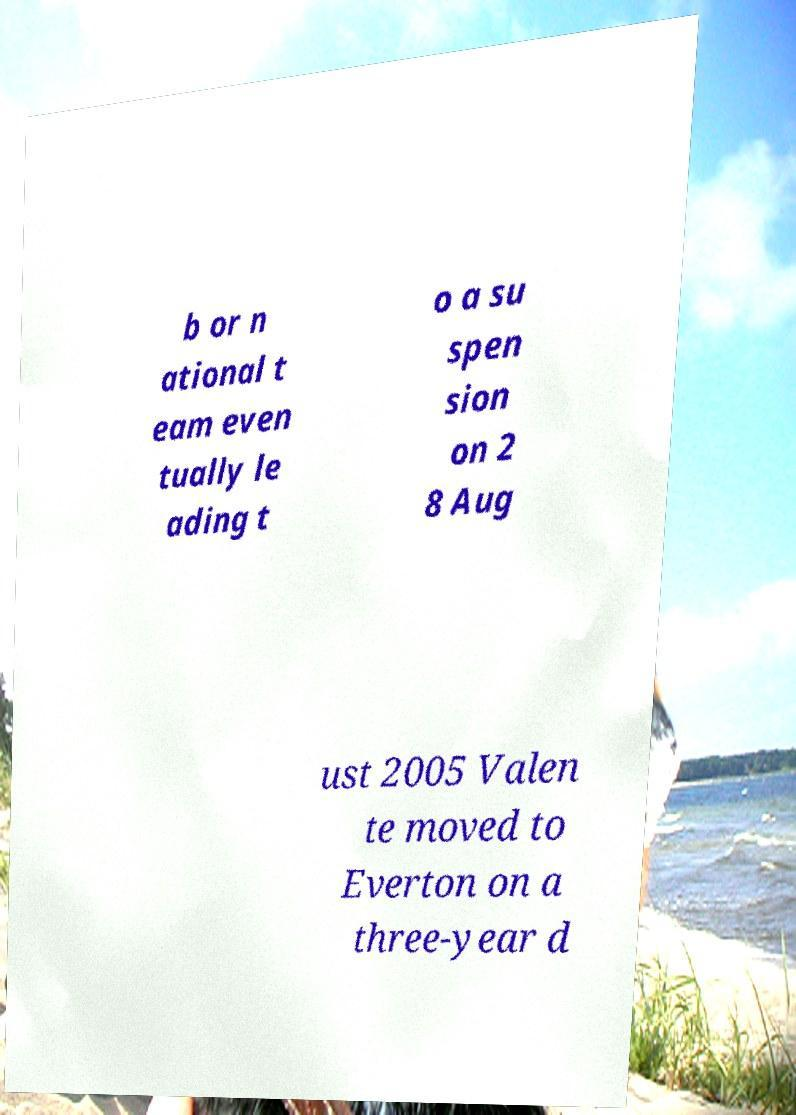Could you extract and type out the text from this image? b or n ational t eam even tually le ading t o a su spen sion on 2 8 Aug ust 2005 Valen te moved to Everton on a three-year d 